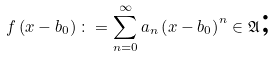Convert formula to latex. <formula><loc_0><loc_0><loc_500><loc_500>f \left ( x - b _ { 0 } \right ) \colon = \sum _ { n = 0 } ^ { \infty } a _ { n } \left ( x - b _ { 0 } \right ) ^ { n } \in \mathfrak { A } \text {;}</formula> 